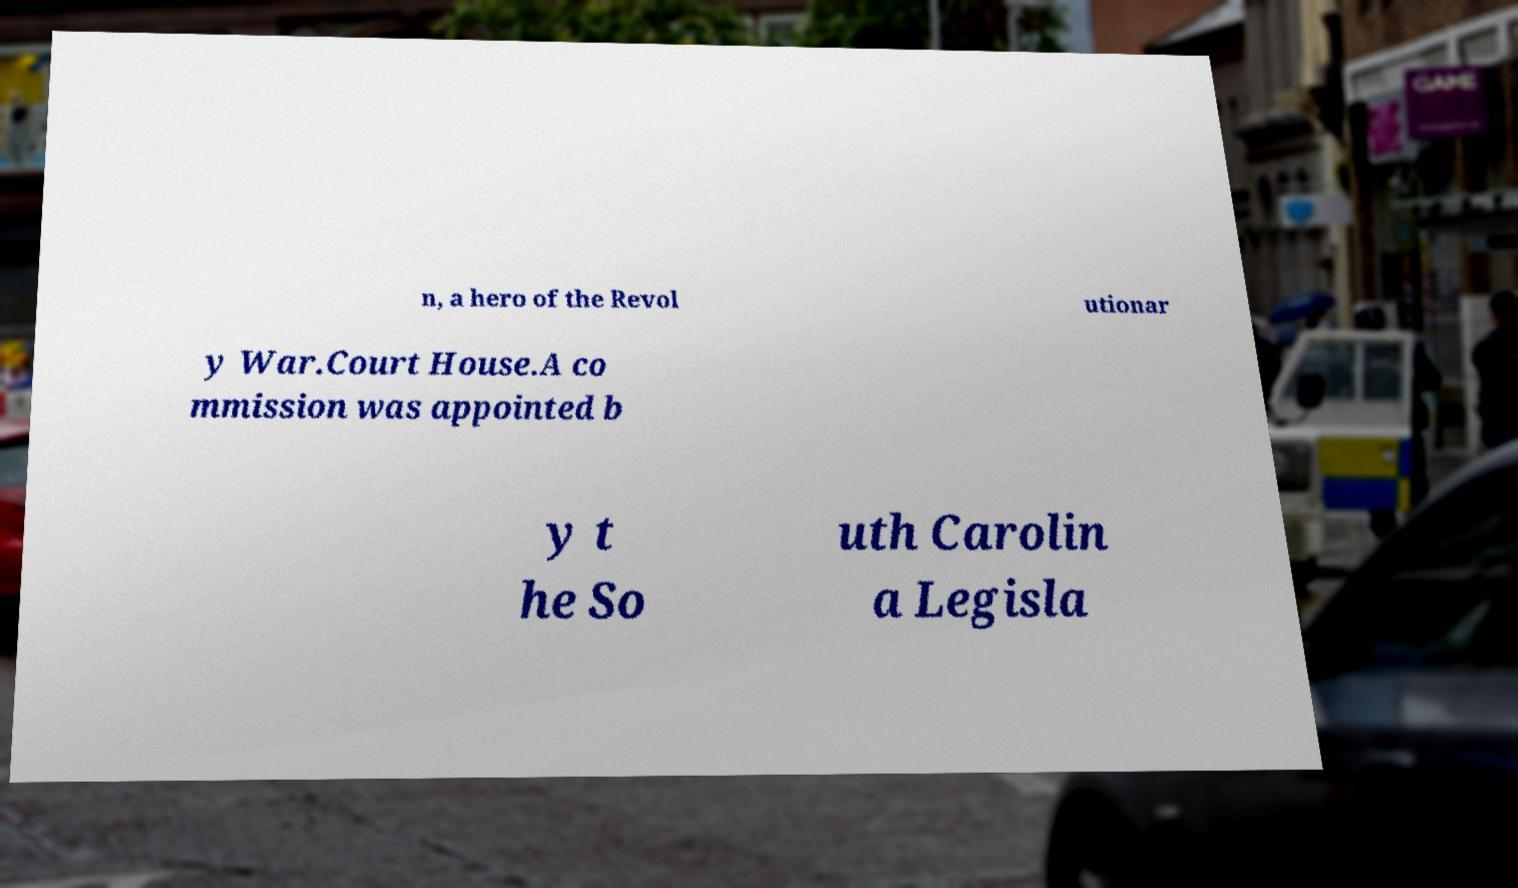Could you assist in decoding the text presented in this image and type it out clearly? n, a hero of the Revol utionar y War.Court House.A co mmission was appointed b y t he So uth Carolin a Legisla 